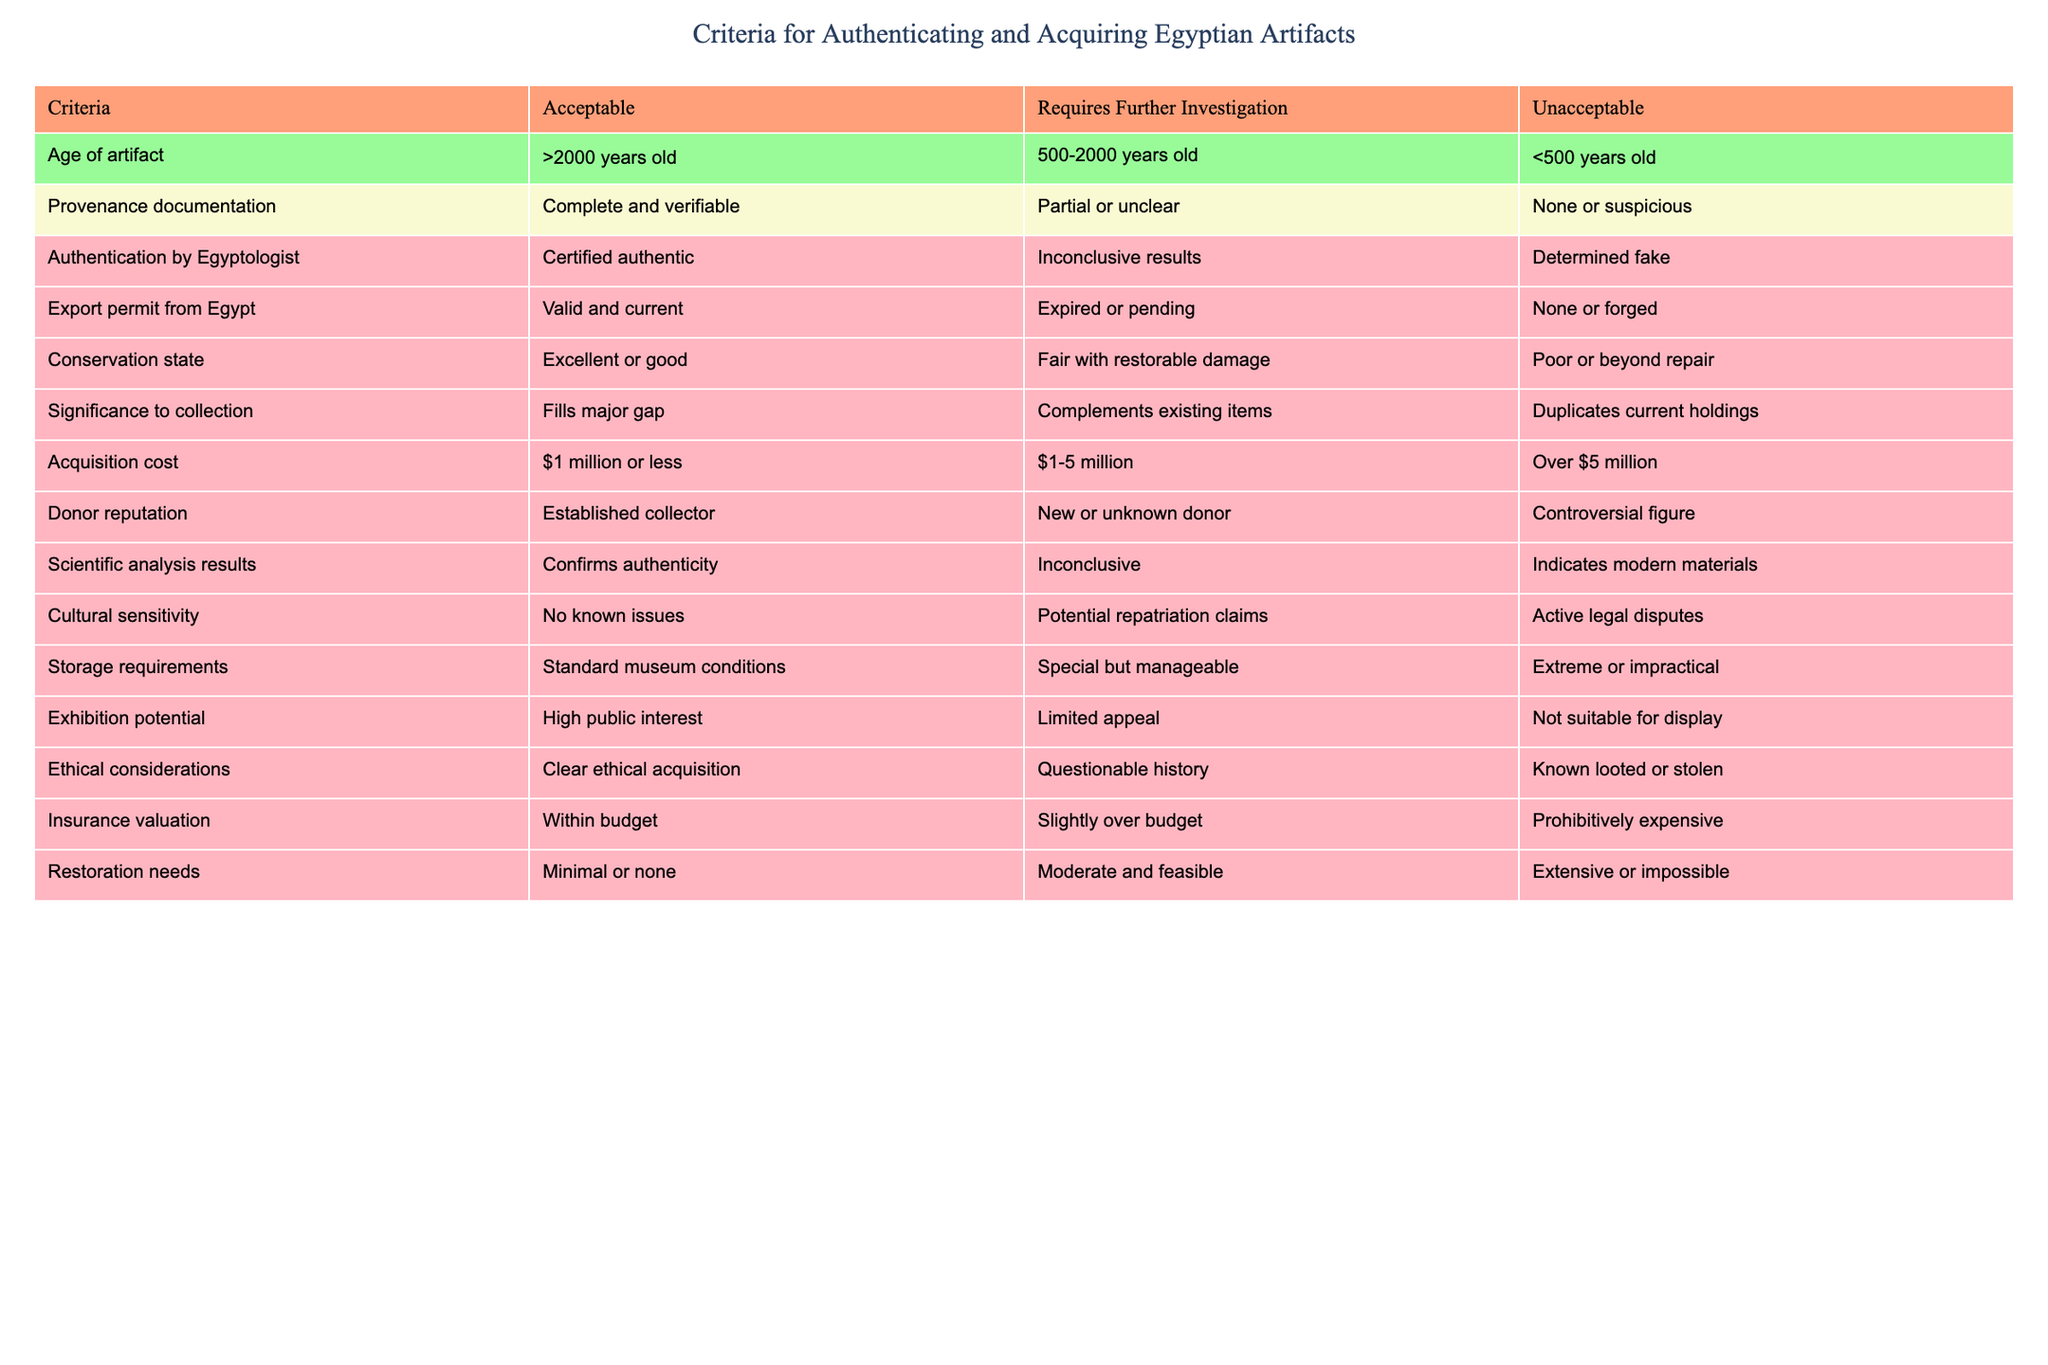What is the maximum acceptable age of an artifact? The table specifies that the acceptable age for an artifact is greater than 2000 years old. Therefore, the maximum acceptable age is anything over that threshold.
Answer: Greater than 2000 years old Is an artifact with incomplete provenance documentation acceptable? According to the table, incomplete provenance documentation falls under "Requires Further Investigation," which is not categorized as acceptable.
Answer: No What are the conditions under which a donor is considered reputable? The table states that a donor is considered reputable if they are an established collector. New or unknown donors are not classified as reputable.
Answer: Established collector If an artifact's acquisition cost is $4 million, what is its category? The cost of $4 million falls within the range of $1-5 million, which classifies it as "Requires Further Investigation" according to the table.
Answer: Requires Further Investigation How many specific criteria categorize artifacts as 'Unacceptable'? By reviewing the table, it can be seen that the criteria for being 'Unacceptable' include "Age of artifact," "Provenance documentation," "Authentication by Egyptologist," "Export permit from Egypt," "Conservation state," "Acquisition cost," "Donor reputation," "Scientific analysis results," "Cultural sensitivity," "Storage requirements," "Exhibition potential," "Ethical considerations," "Insurance valuation," and "Restoration needs." Each one that states conditions falls under that category. Counting these gives a total of 7 criteria.
Answer: 7 What is the significance of the acquisition cost being more than $5 million? The table indicates that if the acquisition cost exceeds $5 million, it is categorized as "Unacceptable." This means that acquisition beyond this limit is not favored in terms of the criteria.
Answer: Unacceptable Which condition requires the most thorough inspection out of all the criteria? The most comprehensive inspection requires "Authentication by Egyptologist." This is indicated by the fact that the "Requires Further Investigation" section includes the ambiguous outcomes that must be addressed through expert analysis.
Answer: Authentication by Egyptologist Is there potential for repatriation claims if the cultural sensitivity category is listed as "No known issues"? The table clearly states that "No known issues" pertaining to cultural sensitivity indicates there are no potential repatriation claims connected to the artifact in question.
Answer: No How does the conservation state affect the acquisition decision? The table indicates that artifacts in "Excellent or good" condition are acceptable. In contrast, those that are "Poor or beyond repair" are deemed unacceptable. "Fair with restorable damage" needs further investigation, suggesting that the conservation state is pivotal in determining the viability of acquisition.
Answer: It significantly affects the decision, categorizing as acceptable, needs investigation, or unacceptable 